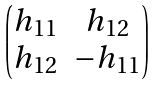<formula> <loc_0><loc_0><loc_500><loc_500>\begin{pmatrix} h _ { 1 1 } & h _ { 1 2 } \\ h _ { 1 2 } & - h _ { 1 1 } \end{pmatrix}</formula> 